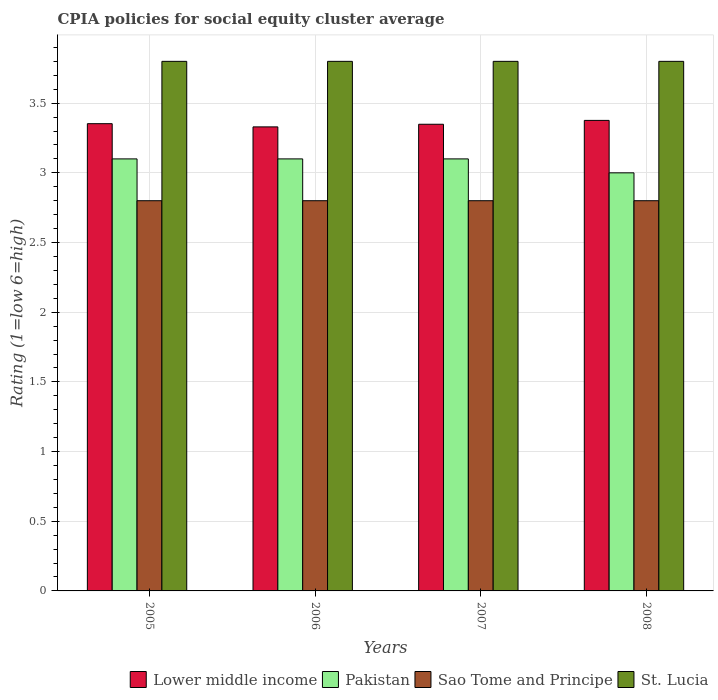Are the number of bars per tick equal to the number of legend labels?
Offer a terse response. Yes. Are the number of bars on each tick of the X-axis equal?
Provide a short and direct response. Yes. How many bars are there on the 3rd tick from the left?
Your response must be concise. 4. What is the label of the 4th group of bars from the left?
Make the answer very short. 2008. In how many cases, is the number of bars for a given year not equal to the number of legend labels?
Give a very brief answer. 0. Across all years, what is the maximum CPIA rating in St. Lucia?
Provide a short and direct response. 3.8. Across all years, what is the minimum CPIA rating in St. Lucia?
Your response must be concise. 3.8. In which year was the CPIA rating in Lower middle income maximum?
Offer a terse response. 2008. What is the total CPIA rating in Pakistan in the graph?
Give a very brief answer. 12.3. What is the difference between the CPIA rating in St. Lucia in 2006 and that in 2008?
Your answer should be very brief. 0. What is the difference between the CPIA rating in Pakistan in 2007 and the CPIA rating in Lower middle income in 2005?
Make the answer very short. -0.25. What is the average CPIA rating in Sao Tome and Principe per year?
Keep it short and to the point. 2.8. In the year 2005, what is the difference between the CPIA rating in Pakistan and CPIA rating in Sao Tome and Principe?
Your response must be concise. 0.3. What is the ratio of the CPIA rating in Sao Tome and Principe in 2007 to that in 2008?
Give a very brief answer. 1. What is the difference between the highest and the lowest CPIA rating in Pakistan?
Make the answer very short. 0.1. In how many years, is the CPIA rating in St. Lucia greater than the average CPIA rating in St. Lucia taken over all years?
Offer a terse response. 0. Is the sum of the CPIA rating in St. Lucia in 2005 and 2008 greater than the maximum CPIA rating in Pakistan across all years?
Offer a terse response. Yes. Is it the case that in every year, the sum of the CPIA rating in Sao Tome and Principe and CPIA rating in Lower middle income is greater than the sum of CPIA rating in Pakistan and CPIA rating in St. Lucia?
Your response must be concise. Yes. What does the 1st bar from the left in 2008 represents?
Give a very brief answer. Lower middle income. Are all the bars in the graph horizontal?
Your answer should be very brief. No. How many years are there in the graph?
Your answer should be compact. 4. What is the difference between two consecutive major ticks on the Y-axis?
Make the answer very short. 0.5. Are the values on the major ticks of Y-axis written in scientific E-notation?
Your answer should be very brief. No. Does the graph contain any zero values?
Keep it short and to the point. No. How many legend labels are there?
Keep it short and to the point. 4. What is the title of the graph?
Make the answer very short. CPIA policies for social equity cluster average. What is the label or title of the Y-axis?
Keep it short and to the point. Rating (1=low 6=high). What is the Rating (1=low 6=high) of Lower middle income in 2005?
Your answer should be very brief. 3.35. What is the Rating (1=low 6=high) in Pakistan in 2005?
Provide a short and direct response. 3.1. What is the Rating (1=low 6=high) of Sao Tome and Principe in 2005?
Give a very brief answer. 2.8. What is the Rating (1=low 6=high) in St. Lucia in 2005?
Offer a terse response. 3.8. What is the Rating (1=low 6=high) in Lower middle income in 2006?
Keep it short and to the point. 3.33. What is the Rating (1=low 6=high) in Pakistan in 2006?
Offer a terse response. 3.1. What is the Rating (1=low 6=high) in Lower middle income in 2007?
Offer a terse response. 3.35. What is the Rating (1=low 6=high) of Sao Tome and Principe in 2007?
Your answer should be compact. 2.8. What is the Rating (1=low 6=high) in St. Lucia in 2007?
Give a very brief answer. 3.8. What is the Rating (1=low 6=high) of Lower middle income in 2008?
Offer a very short reply. 3.38. What is the Rating (1=low 6=high) of St. Lucia in 2008?
Ensure brevity in your answer.  3.8. Across all years, what is the maximum Rating (1=low 6=high) in Lower middle income?
Make the answer very short. 3.38. Across all years, what is the maximum Rating (1=low 6=high) of Pakistan?
Provide a succinct answer. 3.1. Across all years, what is the minimum Rating (1=low 6=high) in Lower middle income?
Make the answer very short. 3.33. Across all years, what is the minimum Rating (1=low 6=high) of Pakistan?
Give a very brief answer. 3. Across all years, what is the minimum Rating (1=low 6=high) of St. Lucia?
Your answer should be very brief. 3.8. What is the total Rating (1=low 6=high) of Lower middle income in the graph?
Ensure brevity in your answer.  13.41. What is the total Rating (1=low 6=high) of Pakistan in the graph?
Offer a terse response. 12.3. What is the total Rating (1=low 6=high) in St. Lucia in the graph?
Your answer should be compact. 15.2. What is the difference between the Rating (1=low 6=high) of Lower middle income in 2005 and that in 2006?
Keep it short and to the point. 0.02. What is the difference between the Rating (1=low 6=high) in Pakistan in 2005 and that in 2006?
Ensure brevity in your answer.  0. What is the difference between the Rating (1=low 6=high) in Sao Tome and Principe in 2005 and that in 2006?
Your answer should be compact. 0. What is the difference between the Rating (1=low 6=high) in Lower middle income in 2005 and that in 2007?
Offer a very short reply. 0. What is the difference between the Rating (1=low 6=high) in St. Lucia in 2005 and that in 2007?
Provide a succinct answer. 0. What is the difference between the Rating (1=low 6=high) of Lower middle income in 2005 and that in 2008?
Your answer should be compact. -0.02. What is the difference between the Rating (1=low 6=high) in Pakistan in 2005 and that in 2008?
Your answer should be very brief. 0.1. What is the difference between the Rating (1=low 6=high) of St. Lucia in 2005 and that in 2008?
Give a very brief answer. 0. What is the difference between the Rating (1=low 6=high) in Lower middle income in 2006 and that in 2007?
Provide a succinct answer. -0.02. What is the difference between the Rating (1=low 6=high) in Pakistan in 2006 and that in 2007?
Provide a succinct answer. 0. What is the difference between the Rating (1=low 6=high) in St. Lucia in 2006 and that in 2007?
Your response must be concise. 0. What is the difference between the Rating (1=low 6=high) in Lower middle income in 2006 and that in 2008?
Make the answer very short. -0.05. What is the difference between the Rating (1=low 6=high) of Lower middle income in 2007 and that in 2008?
Make the answer very short. -0.03. What is the difference between the Rating (1=low 6=high) of Sao Tome and Principe in 2007 and that in 2008?
Your response must be concise. 0. What is the difference between the Rating (1=low 6=high) of St. Lucia in 2007 and that in 2008?
Your response must be concise. 0. What is the difference between the Rating (1=low 6=high) in Lower middle income in 2005 and the Rating (1=low 6=high) in Pakistan in 2006?
Your response must be concise. 0.25. What is the difference between the Rating (1=low 6=high) in Lower middle income in 2005 and the Rating (1=low 6=high) in Sao Tome and Principe in 2006?
Offer a very short reply. 0.55. What is the difference between the Rating (1=low 6=high) in Lower middle income in 2005 and the Rating (1=low 6=high) in St. Lucia in 2006?
Give a very brief answer. -0.45. What is the difference between the Rating (1=low 6=high) in Pakistan in 2005 and the Rating (1=low 6=high) in Sao Tome and Principe in 2006?
Offer a very short reply. 0.3. What is the difference between the Rating (1=low 6=high) of Sao Tome and Principe in 2005 and the Rating (1=low 6=high) of St. Lucia in 2006?
Provide a short and direct response. -1. What is the difference between the Rating (1=low 6=high) in Lower middle income in 2005 and the Rating (1=low 6=high) in Pakistan in 2007?
Make the answer very short. 0.25. What is the difference between the Rating (1=low 6=high) in Lower middle income in 2005 and the Rating (1=low 6=high) in Sao Tome and Principe in 2007?
Offer a terse response. 0.55. What is the difference between the Rating (1=low 6=high) in Lower middle income in 2005 and the Rating (1=low 6=high) in St. Lucia in 2007?
Offer a terse response. -0.45. What is the difference between the Rating (1=low 6=high) in Sao Tome and Principe in 2005 and the Rating (1=low 6=high) in St. Lucia in 2007?
Your response must be concise. -1. What is the difference between the Rating (1=low 6=high) of Lower middle income in 2005 and the Rating (1=low 6=high) of Pakistan in 2008?
Your answer should be compact. 0.35. What is the difference between the Rating (1=low 6=high) of Lower middle income in 2005 and the Rating (1=low 6=high) of Sao Tome and Principe in 2008?
Offer a terse response. 0.55. What is the difference between the Rating (1=low 6=high) of Lower middle income in 2005 and the Rating (1=low 6=high) of St. Lucia in 2008?
Your answer should be compact. -0.45. What is the difference between the Rating (1=low 6=high) in Pakistan in 2005 and the Rating (1=low 6=high) in St. Lucia in 2008?
Keep it short and to the point. -0.7. What is the difference between the Rating (1=low 6=high) in Lower middle income in 2006 and the Rating (1=low 6=high) in Pakistan in 2007?
Provide a short and direct response. 0.23. What is the difference between the Rating (1=low 6=high) of Lower middle income in 2006 and the Rating (1=low 6=high) of Sao Tome and Principe in 2007?
Your answer should be very brief. 0.53. What is the difference between the Rating (1=low 6=high) of Lower middle income in 2006 and the Rating (1=low 6=high) of St. Lucia in 2007?
Ensure brevity in your answer.  -0.47. What is the difference between the Rating (1=low 6=high) of Pakistan in 2006 and the Rating (1=low 6=high) of St. Lucia in 2007?
Ensure brevity in your answer.  -0.7. What is the difference between the Rating (1=low 6=high) of Sao Tome and Principe in 2006 and the Rating (1=low 6=high) of St. Lucia in 2007?
Your answer should be compact. -1. What is the difference between the Rating (1=low 6=high) in Lower middle income in 2006 and the Rating (1=low 6=high) in Pakistan in 2008?
Make the answer very short. 0.33. What is the difference between the Rating (1=low 6=high) in Lower middle income in 2006 and the Rating (1=low 6=high) in Sao Tome and Principe in 2008?
Your answer should be compact. 0.53. What is the difference between the Rating (1=low 6=high) in Lower middle income in 2006 and the Rating (1=low 6=high) in St. Lucia in 2008?
Your answer should be very brief. -0.47. What is the difference between the Rating (1=low 6=high) of Sao Tome and Principe in 2006 and the Rating (1=low 6=high) of St. Lucia in 2008?
Provide a succinct answer. -1. What is the difference between the Rating (1=low 6=high) of Lower middle income in 2007 and the Rating (1=low 6=high) of Pakistan in 2008?
Make the answer very short. 0.35. What is the difference between the Rating (1=low 6=high) in Lower middle income in 2007 and the Rating (1=low 6=high) in Sao Tome and Principe in 2008?
Your answer should be very brief. 0.55. What is the difference between the Rating (1=low 6=high) of Lower middle income in 2007 and the Rating (1=low 6=high) of St. Lucia in 2008?
Your answer should be very brief. -0.45. What is the difference between the Rating (1=low 6=high) in Sao Tome and Principe in 2007 and the Rating (1=low 6=high) in St. Lucia in 2008?
Offer a very short reply. -1. What is the average Rating (1=low 6=high) of Lower middle income per year?
Keep it short and to the point. 3.35. What is the average Rating (1=low 6=high) in Pakistan per year?
Your answer should be compact. 3.08. What is the average Rating (1=low 6=high) of Sao Tome and Principe per year?
Offer a very short reply. 2.8. In the year 2005, what is the difference between the Rating (1=low 6=high) of Lower middle income and Rating (1=low 6=high) of Pakistan?
Your response must be concise. 0.25. In the year 2005, what is the difference between the Rating (1=low 6=high) of Lower middle income and Rating (1=low 6=high) of Sao Tome and Principe?
Your answer should be compact. 0.55. In the year 2005, what is the difference between the Rating (1=low 6=high) in Lower middle income and Rating (1=low 6=high) in St. Lucia?
Keep it short and to the point. -0.45. In the year 2005, what is the difference between the Rating (1=low 6=high) of Pakistan and Rating (1=low 6=high) of Sao Tome and Principe?
Your response must be concise. 0.3. In the year 2005, what is the difference between the Rating (1=low 6=high) of Pakistan and Rating (1=low 6=high) of St. Lucia?
Offer a terse response. -0.7. In the year 2006, what is the difference between the Rating (1=low 6=high) in Lower middle income and Rating (1=low 6=high) in Pakistan?
Ensure brevity in your answer.  0.23. In the year 2006, what is the difference between the Rating (1=low 6=high) of Lower middle income and Rating (1=low 6=high) of Sao Tome and Principe?
Your answer should be very brief. 0.53. In the year 2006, what is the difference between the Rating (1=low 6=high) in Lower middle income and Rating (1=low 6=high) in St. Lucia?
Provide a succinct answer. -0.47. In the year 2006, what is the difference between the Rating (1=low 6=high) of Pakistan and Rating (1=low 6=high) of Sao Tome and Principe?
Offer a terse response. 0.3. In the year 2007, what is the difference between the Rating (1=low 6=high) in Lower middle income and Rating (1=low 6=high) in Pakistan?
Provide a succinct answer. 0.25. In the year 2007, what is the difference between the Rating (1=low 6=high) of Lower middle income and Rating (1=low 6=high) of Sao Tome and Principe?
Your response must be concise. 0.55. In the year 2007, what is the difference between the Rating (1=low 6=high) of Lower middle income and Rating (1=low 6=high) of St. Lucia?
Give a very brief answer. -0.45. In the year 2007, what is the difference between the Rating (1=low 6=high) in Pakistan and Rating (1=low 6=high) in Sao Tome and Principe?
Your answer should be compact. 0.3. In the year 2007, what is the difference between the Rating (1=low 6=high) in Pakistan and Rating (1=low 6=high) in St. Lucia?
Offer a very short reply. -0.7. In the year 2008, what is the difference between the Rating (1=low 6=high) of Lower middle income and Rating (1=low 6=high) of Pakistan?
Keep it short and to the point. 0.38. In the year 2008, what is the difference between the Rating (1=low 6=high) in Lower middle income and Rating (1=low 6=high) in Sao Tome and Principe?
Offer a terse response. 0.58. In the year 2008, what is the difference between the Rating (1=low 6=high) in Lower middle income and Rating (1=low 6=high) in St. Lucia?
Ensure brevity in your answer.  -0.42. In the year 2008, what is the difference between the Rating (1=low 6=high) of Pakistan and Rating (1=low 6=high) of Sao Tome and Principe?
Give a very brief answer. 0.2. What is the ratio of the Rating (1=low 6=high) of Lower middle income in 2005 to that in 2006?
Offer a terse response. 1.01. What is the ratio of the Rating (1=low 6=high) of Pakistan in 2005 to that in 2006?
Offer a terse response. 1. What is the ratio of the Rating (1=low 6=high) in Sao Tome and Principe in 2005 to that in 2006?
Offer a very short reply. 1. What is the ratio of the Rating (1=low 6=high) of Pakistan in 2005 to that in 2007?
Keep it short and to the point. 1. What is the ratio of the Rating (1=low 6=high) of Sao Tome and Principe in 2005 to that in 2007?
Provide a succinct answer. 1. What is the ratio of the Rating (1=low 6=high) in St. Lucia in 2005 to that in 2007?
Give a very brief answer. 1. What is the ratio of the Rating (1=low 6=high) of Pakistan in 2005 to that in 2008?
Give a very brief answer. 1.03. What is the ratio of the Rating (1=low 6=high) in Sao Tome and Principe in 2005 to that in 2008?
Offer a terse response. 1. What is the ratio of the Rating (1=low 6=high) in St. Lucia in 2005 to that in 2008?
Your answer should be compact. 1. What is the ratio of the Rating (1=low 6=high) of Lower middle income in 2006 to that in 2007?
Give a very brief answer. 0.99. What is the ratio of the Rating (1=low 6=high) of Pakistan in 2006 to that in 2007?
Offer a very short reply. 1. What is the ratio of the Rating (1=low 6=high) in Lower middle income in 2006 to that in 2008?
Your answer should be compact. 0.99. What is the ratio of the Rating (1=low 6=high) of Sao Tome and Principe in 2006 to that in 2008?
Your response must be concise. 1. What is the ratio of the Rating (1=low 6=high) in St. Lucia in 2006 to that in 2008?
Keep it short and to the point. 1. What is the ratio of the Rating (1=low 6=high) of Sao Tome and Principe in 2007 to that in 2008?
Give a very brief answer. 1. What is the ratio of the Rating (1=low 6=high) in St. Lucia in 2007 to that in 2008?
Your response must be concise. 1. What is the difference between the highest and the second highest Rating (1=low 6=high) of Lower middle income?
Your response must be concise. 0.02. What is the difference between the highest and the second highest Rating (1=low 6=high) in Pakistan?
Your answer should be very brief. 0. What is the difference between the highest and the second highest Rating (1=low 6=high) in St. Lucia?
Keep it short and to the point. 0. What is the difference between the highest and the lowest Rating (1=low 6=high) in Lower middle income?
Offer a terse response. 0.05. What is the difference between the highest and the lowest Rating (1=low 6=high) in Sao Tome and Principe?
Your response must be concise. 0. 